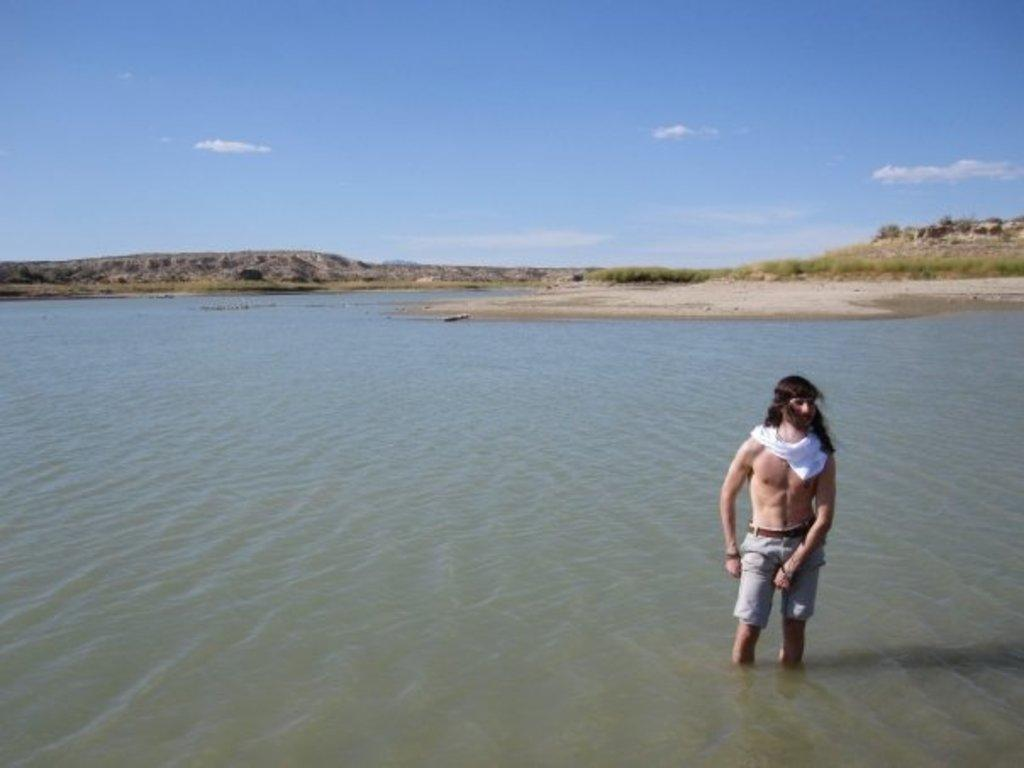What is the person in the image doing? The person is standing in the water. What can be seen beneath the person's feet in the image? The ground is visible in the image. What type of vegetation is present in the image? There are plants in the image. What is visible above the person's head in the image? The sky is visible in the image. What letter can be seen floating in the water near the person? There is no letter visible in the image; it only shows a person standing in the water. 